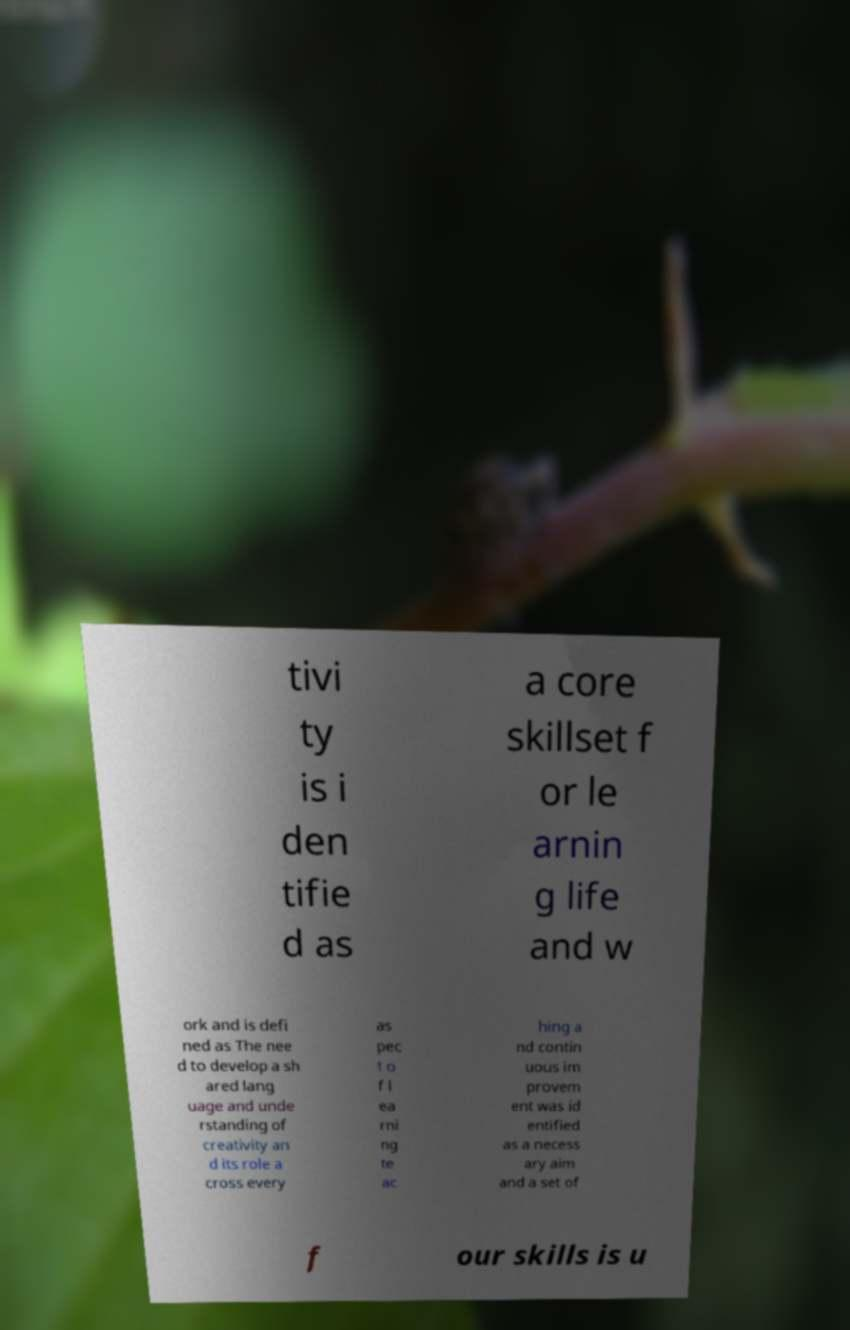For documentation purposes, I need the text within this image transcribed. Could you provide that? tivi ty is i den tifie d as a core skillset f or le arnin g life and w ork and is defi ned as The nee d to develop a sh ared lang uage and unde rstanding of creativity an d its role a cross every as pec t o f l ea rni ng te ac hing a nd contin uous im provem ent was id entified as a necess ary aim and a set of f our skills is u 